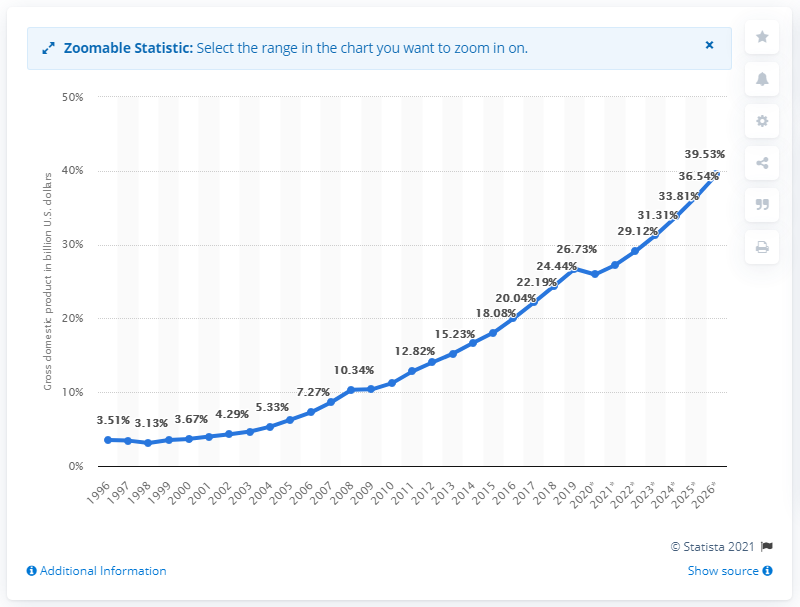Highlight a few significant elements in this photo. In 2019, the gross domestic product of Cambodia was 26.73. 